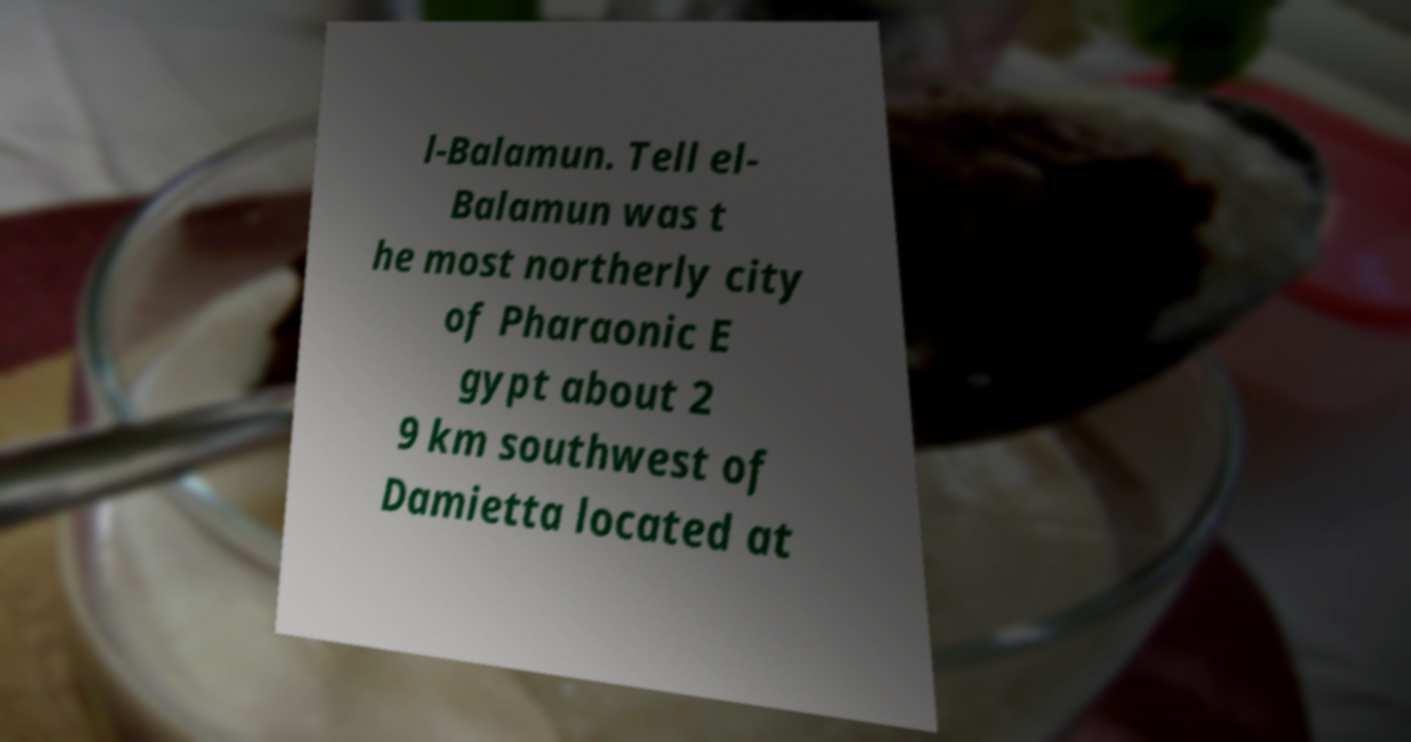Could you assist in decoding the text presented in this image and type it out clearly? l-Balamun. Tell el- Balamun was t he most northerly city of Pharaonic E gypt about 2 9 km southwest of Damietta located at 